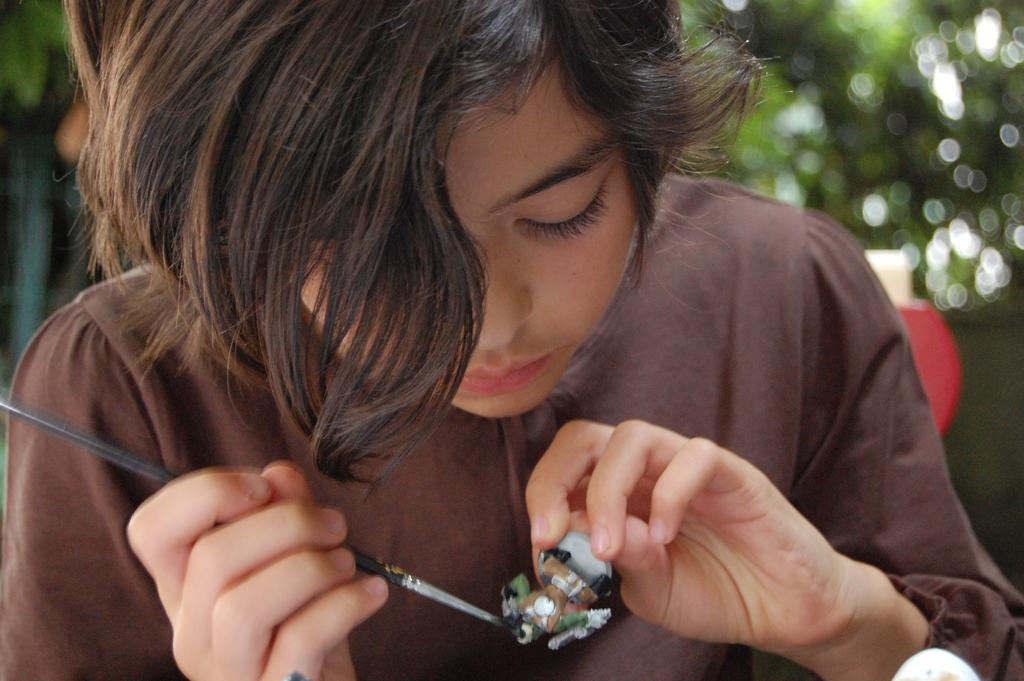What is the woman holding in her hand in the image? The woman is holding a toy and a paintbrush in the image. What is the woman's focus in the image? The woman is looking at the toy in the image. Can you describe the background of the image? The background is blurred in the image. What type of vegetation can be seen in the image? There is a tree visible in the image. What type of pen is the woman using to draw the curve on the tree in the image? There is no pen or curve visible in the image; the woman is holding a toy and a paintbrush, and there is a tree in the background. 